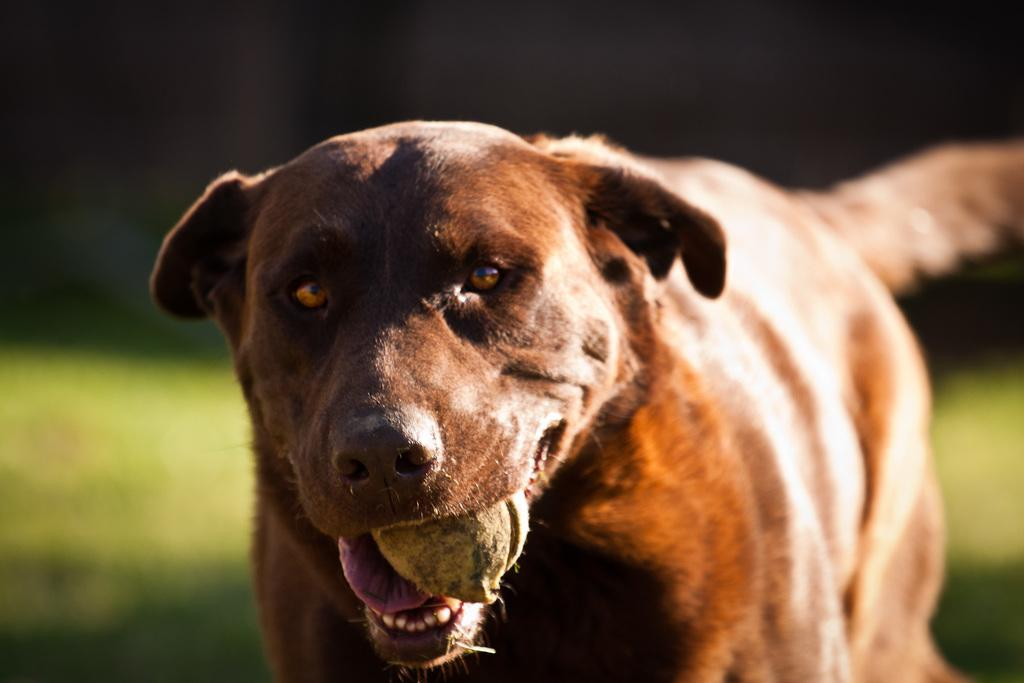What type of animal is in the image? There is a dog in the image. What is the dog holding in its mouth? The dog has an object in its mouth. What is the ground surface like in the image? There is grass on the ground in the image. How would you describe the background of the image? The background of the image is blurry. How many cows are visible in the image? There are no cows present in the image; it features a dog with an object in its mouth, grass on the ground, and a blurry background. 